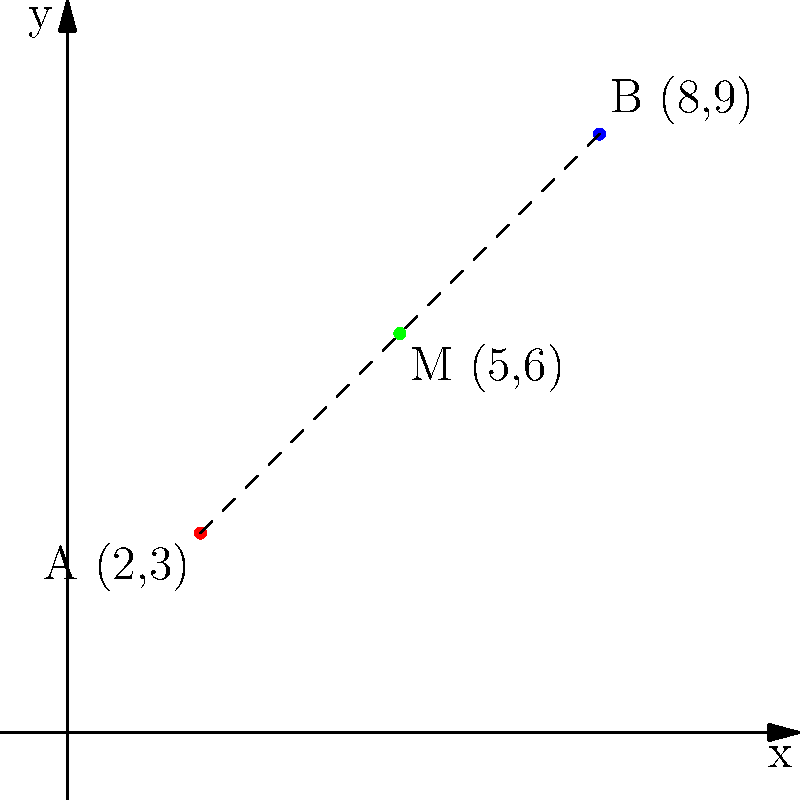As part of your duties, you need to determine the midpoint between two diplomatic residences. Residence A is located at coordinates (2,3) and Residence B is at (8,9) on the city map. What are the coordinates of the midpoint M between these two residences? To find the midpoint between two points, we use the midpoint formula:

$$ M_x = \frac{x_1 + x_2}{2}, \quad M_y = \frac{y_1 + y_2}{2} $$

Where $(x_1, y_1)$ are the coordinates of the first point and $(x_2, y_2)$ are the coordinates of the second point.

For Residence A: $(x_1, y_1) = (2, 3)$
For Residence B: $(x_2, y_2) = (8, 9)$

Step 1: Calculate the x-coordinate of the midpoint:
$$ M_x = \frac{x_1 + x_2}{2} = \frac{2 + 8}{2} = \frac{10}{2} = 5 $$

Step 2: Calculate the y-coordinate of the midpoint:
$$ M_y = \frac{y_1 + y_2}{2} = \frac{3 + 9}{2} = \frac{12}{2} = 6 $$

Therefore, the coordinates of the midpoint M are (5, 6).
Answer: (5, 6) 